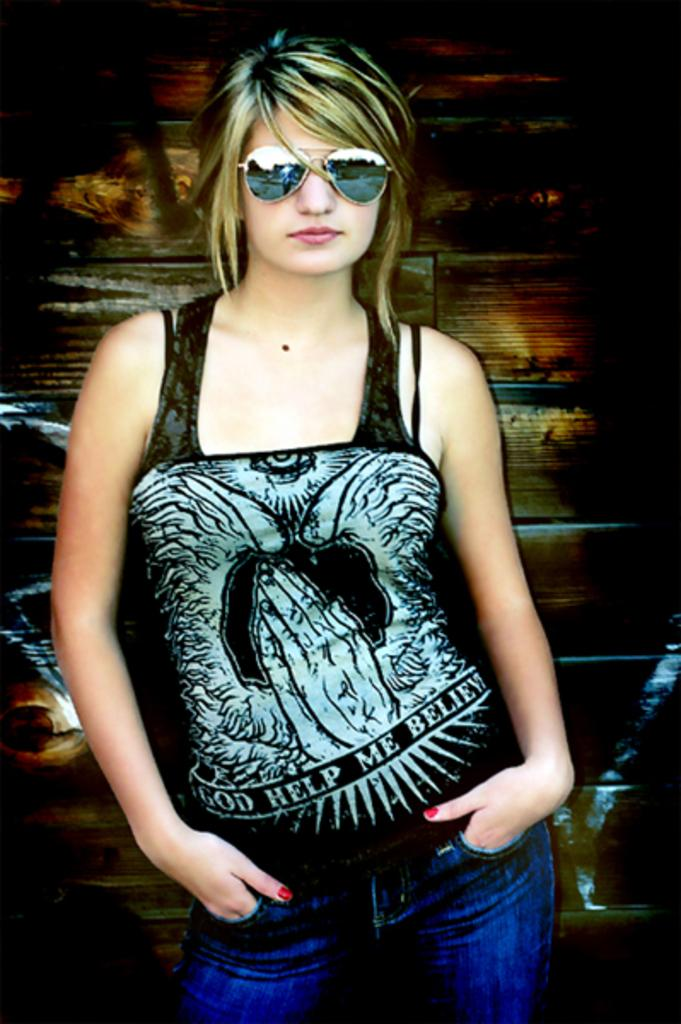What is the main subject of the image? There is a picture of a woman in the image. What can be seen behind the woman in the image? The background of the image appears to be a wooden wall. How many chickens are present in the image? There are no chickens present in the image; it features a picture of a woman with a wooden wall background. 